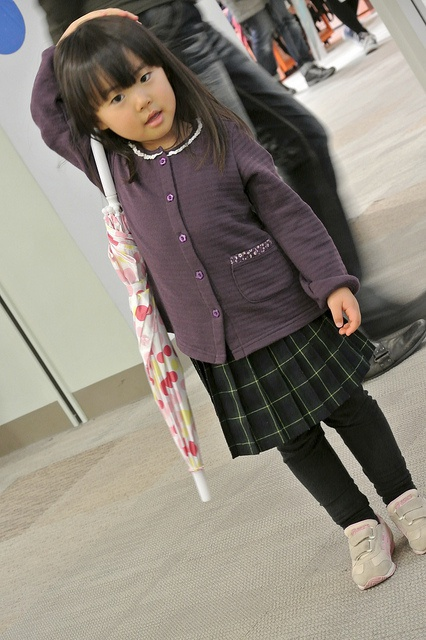Describe the objects in this image and their specific colors. I can see people in gray and black tones, people in gray and black tones, umbrella in gray, lightgray, darkgray, lightpink, and beige tones, people in gray, black, and darkgray tones, and people in gray, black, darkgray, and lightgray tones in this image. 